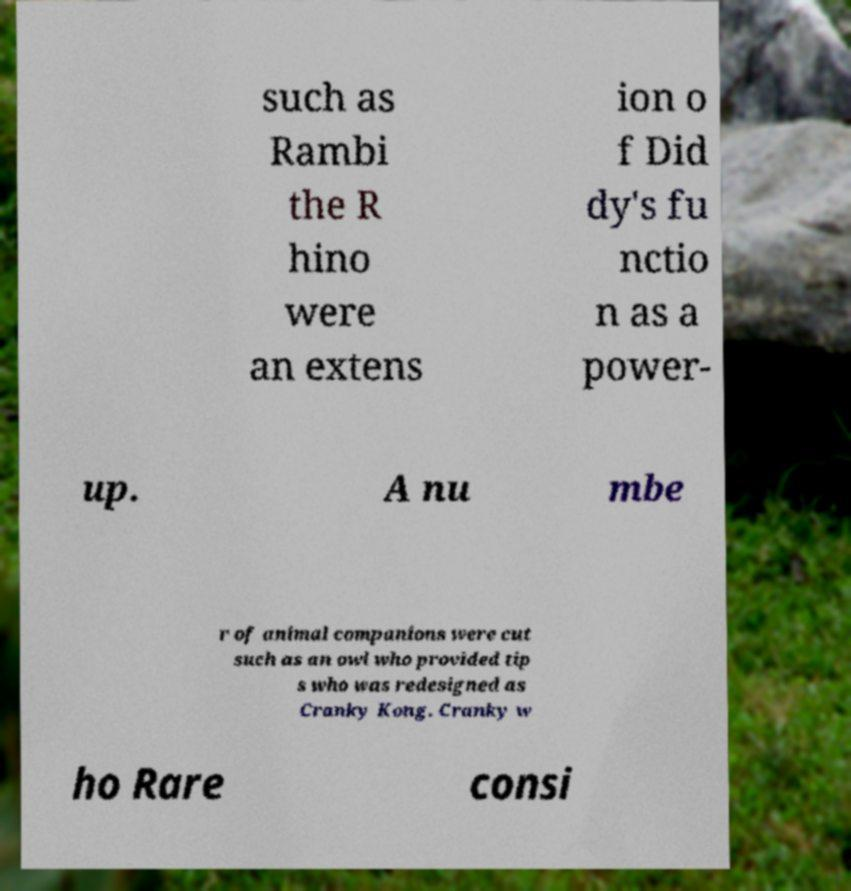What messages or text are displayed in this image? I need them in a readable, typed format. such as Rambi the R hino were an extens ion o f Did dy's fu nctio n as a power- up. A nu mbe r of animal companions were cut such as an owl who provided tip s who was redesigned as Cranky Kong. Cranky w ho Rare consi 